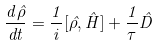<formula> <loc_0><loc_0><loc_500><loc_500>\frac { d \hat { \rho } } { d t } = \frac { 1 } { i } [ \hat { \rho } , \hat { H } ] + \frac { 1 } { \tau } \hat { D }</formula> 